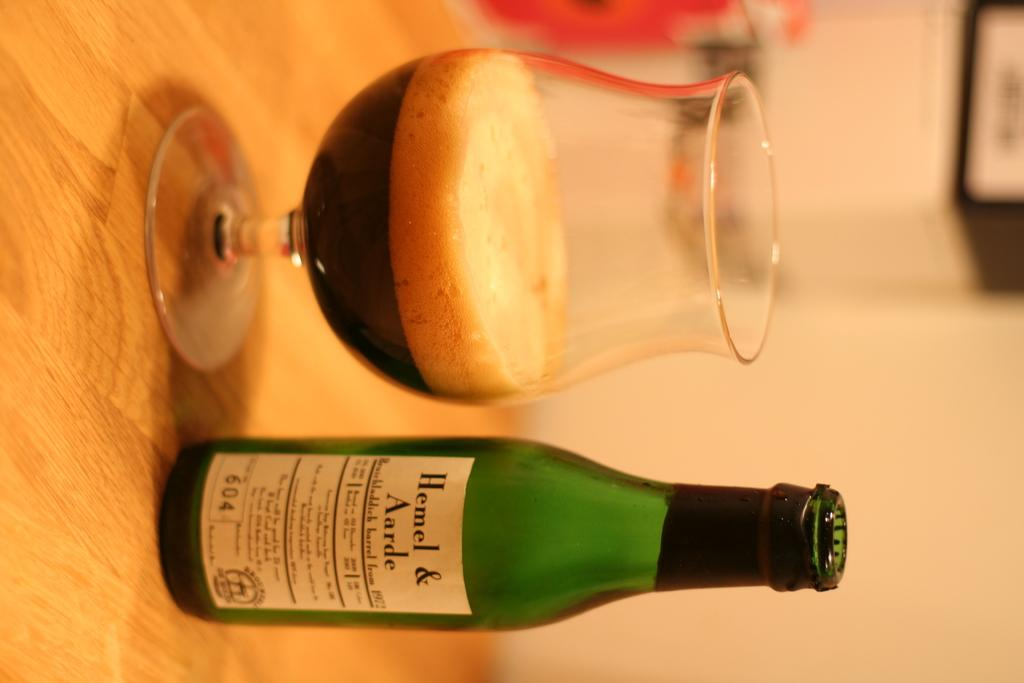Provide a one-sentence caption for the provided image. Bottle of hemel and aarde with a glass half empty on a table. 